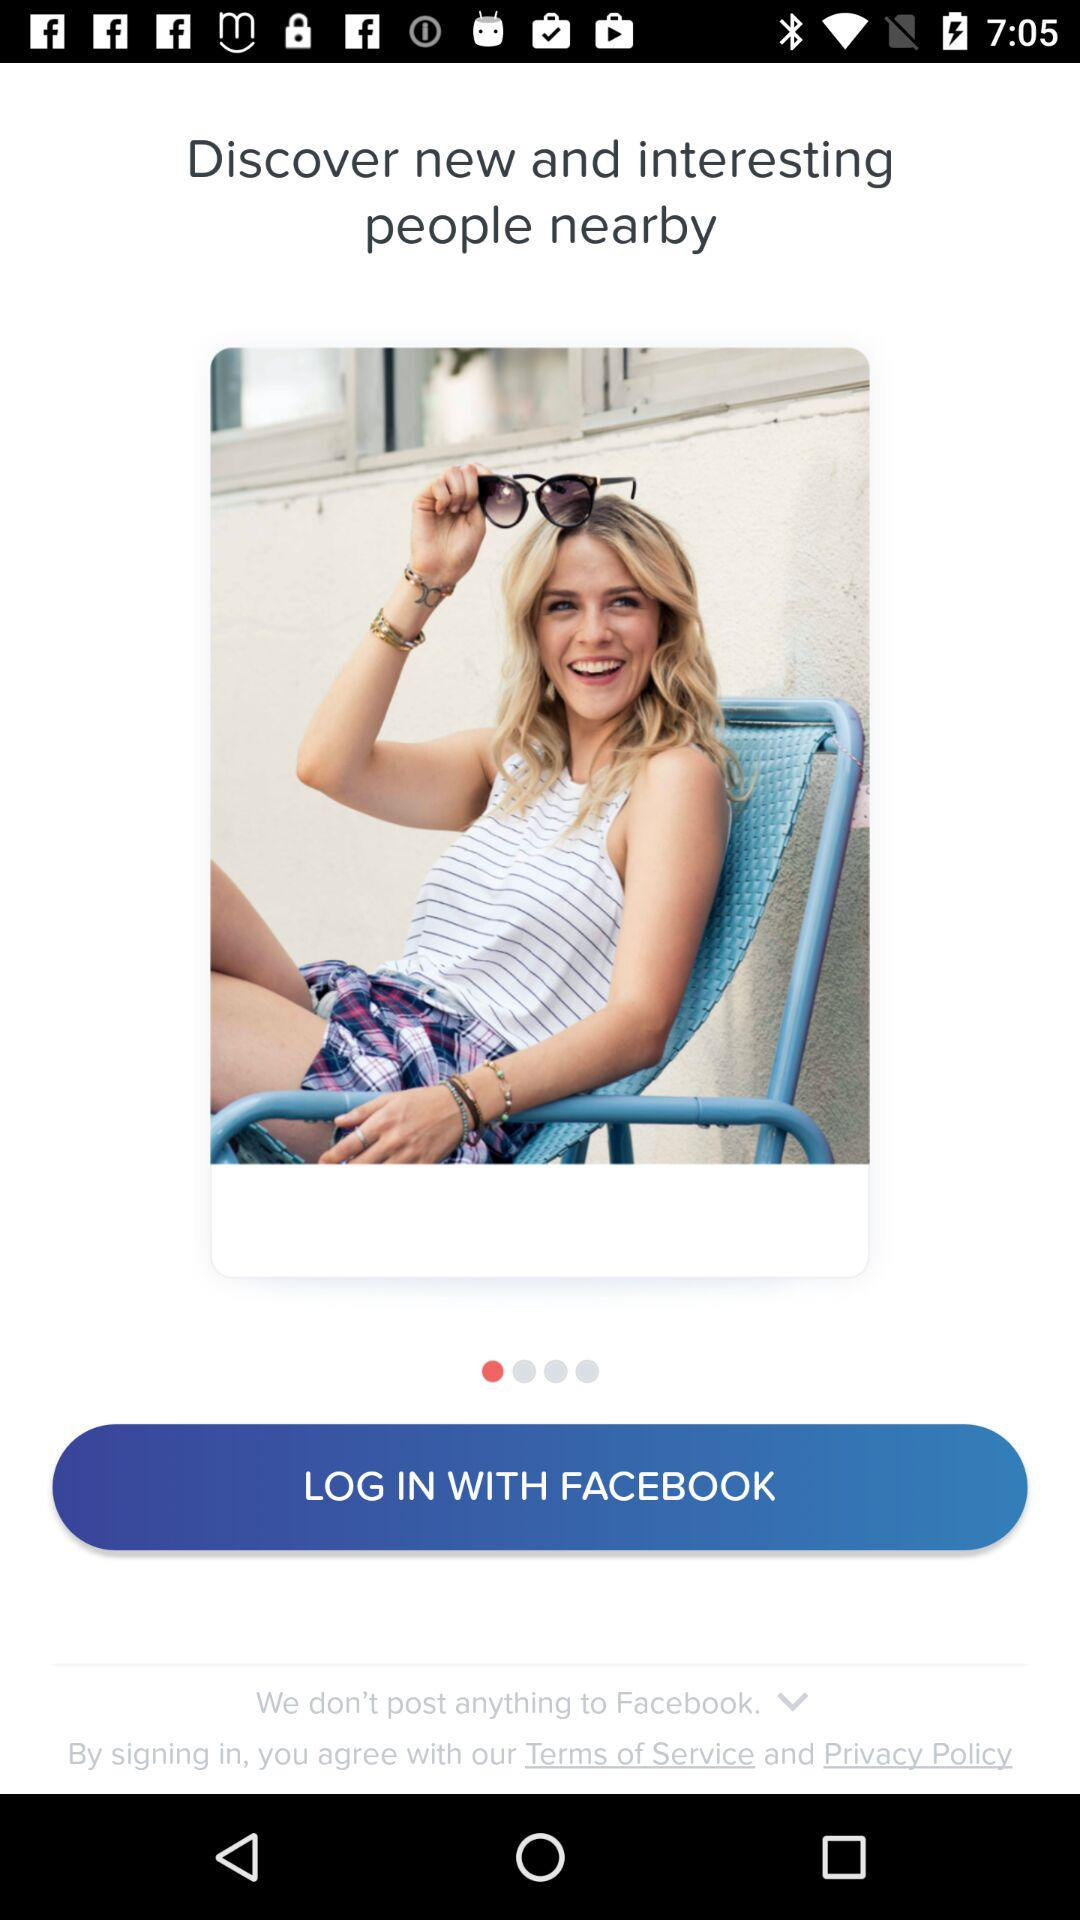What application can be used to log in? The application that can be used to log in is "FACEBOOK". 